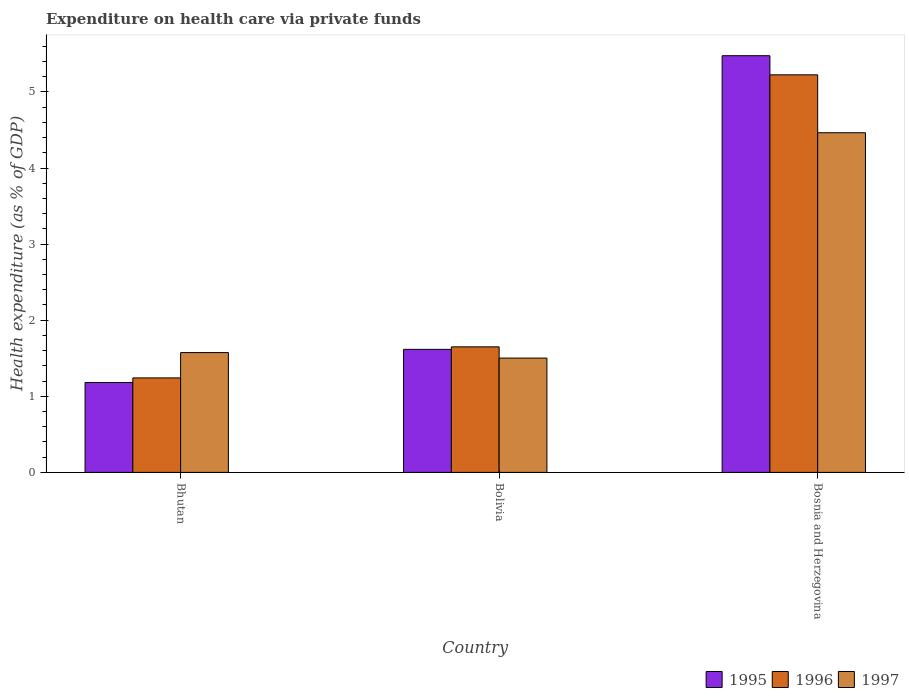How many bars are there on the 2nd tick from the left?
Offer a very short reply. 3. What is the label of the 1st group of bars from the left?
Make the answer very short. Bhutan. What is the expenditure made on health care in 1997 in Bosnia and Herzegovina?
Your response must be concise. 4.46. Across all countries, what is the maximum expenditure made on health care in 1995?
Keep it short and to the point. 5.48. Across all countries, what is the minimum expenditure made on health care in 1995?
Offer a very short reply. 1.18. In which country was the expenditure made on health care in 1996 maximum?
Ensure brevity in your answer.  Bosnia and Herzegovina. In which country was the expenditure made on health care in 1995 minimum?
Give a very brief answer. Bhutan. What is the total expenditure made on health care in 1995 in the graph?
Provide a succinct answer. 8.27. What is the difference between the expenditure made on health care in 1995 in Bolivia and that in Bosnia and Herzegovina?
Your response must be concise. -3.86. What is the difference between the expenditure made on health care in 1997 in Bhutan and the expenditure made on health care in 1996 in Bolivia?
Give a very brief answer. -0.08. What is the average expenditure made on health care in 1996 per country?
Make the answer very short. 2.71. What is the difference between the expenditure made on health care of/in 1995 and expenditure made on health care of/in 1997 in Bosnia and Herzegovina?
Ensure brevity in your answer.  1.01. What is the ratio of the expenditure made on health care in 1997 in Bhutan to that in Bosnia and Herzegovina?
Keep it short and to the point. 0.35. Is the expenditure made on health care in 1996 in Bhutan less than that in Bolivia?
Your answer should be very brief. Yes. What is the difference between the highest and the second highest expenditure made on health care in 1996?
Keep it short and to the point. -3.57. What is the difference between the highest and the lowest expenditure made on health care in 1996?
Your answer should be compact. 3.98. How many countries are there in the graph?
Make the answer very short. 3. What is the difference between two consecutive major ticks on the Y-axis?
Make the answer very short. 1. Does the graph contain any zero values?
Offer a very short reply. No. How are the legend labels stacked?
Make the answer very short. Horizontal. What is the title of the graph?
Offer a terse response. Expenditure on health care via private funds. Does "2011" appear as one of the legend labels in the graph?
Provide a short and direct response. No. What is the label or title of the X-axis?
Your answer should be compact. Country. What is the label or title of the Y-axis?
Offer a terse response. Health expenditure (as % of GDP). What is the Health expenditure (as % of GDP) of 1995 in Bhutan?
Keep it short and to the point. 1.18. What is the Health expenditure (as % of GDP) of 1996 in Bhutan?
Your answer should be compact. 1.24. What is the Health expenditure (as % of GDP) in 1997 in Bhutan?
Make the answer very short. 1.57. What is the Health expenditure (as % of GDP) in 1995 in Bolivia?
Give a very brief answer. 1.62. What is the Health expenditure (as % of GDP) in 1996 in Bolivia?
Give a very brief answer. 1.65. What is the Health expenditure (as % of GDP) in 1997 in Bolivia?
Your answer should be very brief. 1.5. What is the Health expenditure (as % of GDP) in 1995 in Bosnia and Herzegovina?
Keep it short and to the point. 5.48. What is the Health expenditure (as % of GDP) in 1996 in Bosnia and Herzegovina?
Offer a terse response. 5.22. What is the Health expenditure (as % of GDP) in 1997 in Bosnia and Herzegovina?
Keep it short and to the point. 4.46. Across all countries, what is the maximum Health expenditure (as % of GDP) of 1995?
Keep it short and to the point. 5.48. Across all countries, what is the maximum Health expenditure (as % of GDP) of 1996?
Your answer should be very brief. 5.22. Across all countries, what is the maximum Health expenditure (as % of GDP) of 1997?
Your answer should be very brief. 4.46. Across all countries, what is the minimum Health expenditure (as % of GDP) of 1995?
Ensure brevity in your answer.  1.18. Across all countries, what is the minimum Health expenditure (as % of GDP) of 1996?
Your response must be concise. 1.24. Across all countries, what is the minimum Health expenditure (as % of GDP) of 1997?
Offer a very short reply. 1.5. What is the total Health expenditure (as % of GDP) in 1995 in the graph?
Offer a very short reply. 8.28. What is the total Health expenditure (as % of GDP) in 1996 in the graph?
Your answer should be very brief. 8.12. What is the total Health expenditure (as % of GDP) in 1997 in the graph?
Offer a very short reply. 7.54. What is the difference between the Health expenditure (as % of GDP) in 1995 in Bhutan and that in Bolivia?
Your answer should be very brief. -0.44. What is the difference between the Health expenditure (as % of GDP) in 1996 in Bhutan and that in Bolivia?
Provide a succinct answer. -0.41. What is the difference between the Health expenditure (as % of GDP) in 1997 in Bhutan and that in Bolivia?
Make the answer very short. 0.07. What is the difference between the Health expenditure (as % of GDP) of 1995 in Bhutan and that in Bosnia and Herzegovina?
Ensure brevity in your answer.  -4.29. What is the difference between the Health expenditure (as % of GDP) in 1996 in Bhutan and that in Bosnia and Herzegovina?
Your answer should be very brief. -3.98. What is the difference between the Health expenditure (as % of GDP) of 1997 in Bhutan and that in Bosnia and Herzegovina?
Keep it short and to the point. -2.89. What is the difference between the Health expenditure (as % of GDP) in 1995 in Bolivia and that in Bosnia and Herzegovina?
Your answer should be compact. -3.86. What is the difference between the Health expenditure (as % of GDP) in 1996 in Bolivia and that in Bosnia and Herzegovina?
Keep it short and to the point. -3.57. What is the difference between the Health expenditure (as % of GDP) of 1997 in Bolivia and that in Bosnia and Herzegovina?
Your response must be concise. -2.96. What is the difference between the Health expenditure (as % of GDP) of 1995 in Bhutan and the Health expenditure (as % of GDP) of 1996 in Bolivia?
Keep it short and to the point. -0.47. What is the difference between the Health expenditure (as % of GDP) in 1995 in Bhutan and the Health expenditure (as % of GDP) in 1997 in Bolivia?
Provide a short and direct response. -0.32. What is the difference between the Health expenditure (as % of GDP) of 1996 in Bhutan and the Health expenditure (as % of GDP) of 1997 in Bolivia?
Keep it short and to the point. -0.26. What is the difference between the Health expenditure (as % of GDP) in 1995 in Bhutan and the Health expenditure (as % of GDP) in 1996 in Bosnia and Herzegovina?
Make the answer very short. -4.04. What is the difference between the Health expenditure (as % of GDP) of 1995 in Bhutan and the Health expenditure (as % of GDP) of 1997 in Bosnia and Herzegovina?
Your response must be concise. -3.28. What is the difference between the Health expenditure (as % of GDP) of 1996 in Bhutan and the Health expenditure (as % of GDP) of 1997 in Bosnia and Herzegovina?
Offer a very short reply. -3.22. What is the difference between the Health expenditure (as % of GDP) in 1995 in Bolivia and the Health expenditure (as % of GDP) in 1996 in Bosnia and Herzegovina?
Keep it short and to the point. -3.61. What is the difference between the Health expenditure (as % of GDP) of 1995 in Bolivia and the Health expenditure (as % of GDP) of 1997 in Bosnia and Herzegovina?
Your answer should be very brief. -2.85. What is the difference between the Health expenditure (as % of GDP) of 1996 in Bolivia and the Health expenditure (as % of GDP) of 1997 in Bosnia and Herzegovina?
Your answer should be compact. -2.81. What is the average Health expenditure (as % of GDP) of 1995 per country?
Make the answer very short. 2.76. What is the average Health expenditure (as % of GDP) of 1996 per country?
Your answer should be compact. 2.71. What is the average Health expenditure (as % of GDP) in 1997 per country?
Provide a short and direct response. 2.51. What is the difference between the Health expenditure (as % of GDP) in 1995 and Health expenditure (as % of GDP) in 1996 in Bhutan?
Offer a very short reply. -0.06. What is the difference between the Health expenditure (as % of GDP) in 1995 and Health expenditure (as % of GDP) in 1997 in Bhutan?
Make the answer very short. -0.39. What is the difference between the Health expenditure (as % of GDP) in 1996 and Health expenditure (as % of GDP) in 1997 in Bhutan?
Your response must be concise. -0.33. What is the difference between the Health expenditure (as % of GDP) in 1995 and Health expenditure (as % of GDP) in 1996 in Bolivia?
Ensure brevity in your answer.  -0.03. What is the difference between the Health expenditure (as % of GDP) in 1995 and Health expenditure (as % of GDP) in 1997 in Bolivia?
Ensure brevity in your answer.  0.11. What is the difference between the Health expenditure (as % of GDP) in 1996 and Health expenditure (as % of GDP) in 1997 in Bolivia?
Offer a very short reply. 0.15. What is the difference between the Health expenditure (as % of GDP) of 1995 and Health expenditure (as % of GDP) of 1996 in Bosnia and Herzegovina?
Offer a very short reply. 0.25. What is the difference between the Health expenditure (as % of GDP) of 1995 and Health expenditure (as % of GDP) of 1997 in Bosnia and Herzegovina?
Provide a short and direct response. 1.01. What is the difference between the Health expenditure (as % of GDP) in 1996 and Health expenditure (as % of GDP) in 1997 in Bosnia and Herzegovina?
Your answer should be very brief. 0.76. What is the ratio of the Health expenditure (as % of GDP) of 1995 in Bhutan to that in Bolivia?
Your answer should be very brief. 0.73. What is the ratio of the Health expenditure (as % of GDP) in 1996 in Bhutan to that in Bolivia?
Offer a terse response. 0.75. What is the ratio of the Health expenditure (as % of GDP) of 1997 in Bhutan to that in Bolivia?
Make the answer very short. 1.05. What is the ratio of the Health expenditure (as % of GDP) of 1995 in Bhutan to that in Bosnia and Herzegovina?
Offer a very short reply. 0.22. What is the ratio of the Health expenditure (as % of GDP) in 1996 in Bhutan to that in Bosnia and Herzegovina?
Your answer should be compact. 0.24. What is the ratio of the Health expenditure (as % of GDP) in 1997 in Bhutan to that in Bosnia and Herzegovina?
Your answer should be compact. 0.35. What is the ratio of the Health expenditure (as % of GDP) of 1995 in Bolivia to that in Bosnia and Herzegovina?
Offer a terse response. 0.3. What is the ratio of the Health expenditure (as % of GDP) in 1996 in Bolivia to that in Bosnia and Herzegovina?
Offer a very short reply. 0.32. What is the ratio of the Health expenditure (as % of GDP) in 1997 in Bolivia to that in Bosnia and Herzegovina?
Your answer should be compact. 0.34. What is the difference between the highest and the second highest Health expenditure (as % of GDP) of 1995?
Your response must be concise. 3.86. What is the difference between the highest and the second highest Health expenditure (as % of GDP) in 1996?
Your answer should be compact. 3.57. What is the difference between the highest and the second highest Health expenditure (as % of GDP) of 1997?
Your answer should be compact. 2.89. What is the difference between the highest and the lowest Health expenditure (as % of GDP) in 1995?
Offer a terse response. 4.29. What is the difference between the highest and the lowest Health expenditure (as % of GDP) of 1996?
Keep it short and to the point. 3.98. What is the difference between the highest and the lowest Health expenditure (as % of GDP) of 1997?
Provide a short and direct response. 2.96. 